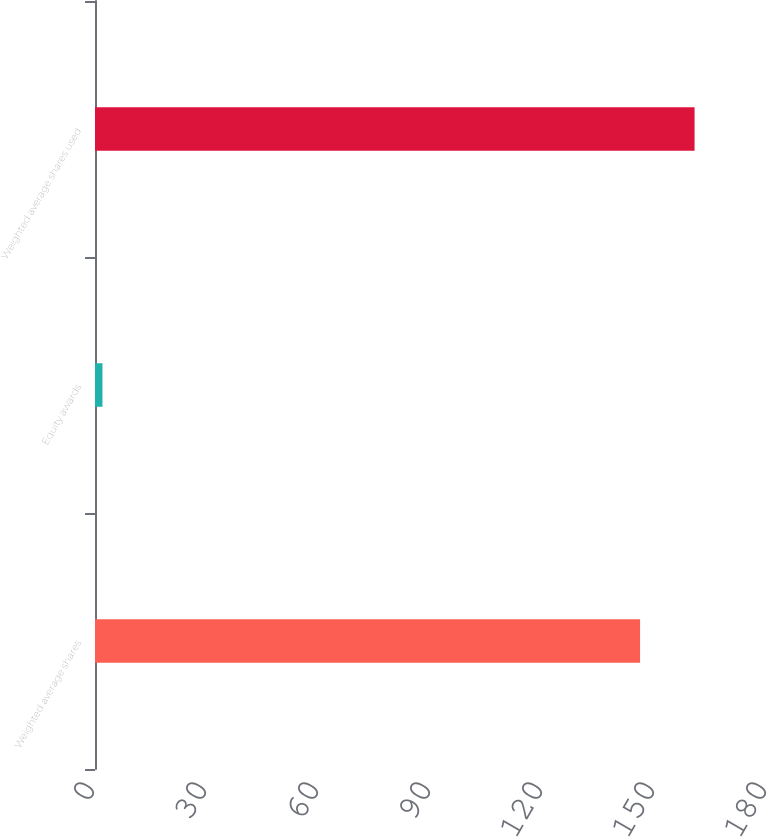Convert chart to OTSL. <chart><loc_0><loc_0><loc_500><loc_500><bar_chart><fcel>Weighted average shares<fcel>Equity awards<fcel>Weighted average shares used<nl><fcel>146<fcel>2<fcel>160.6<nl></chart> 